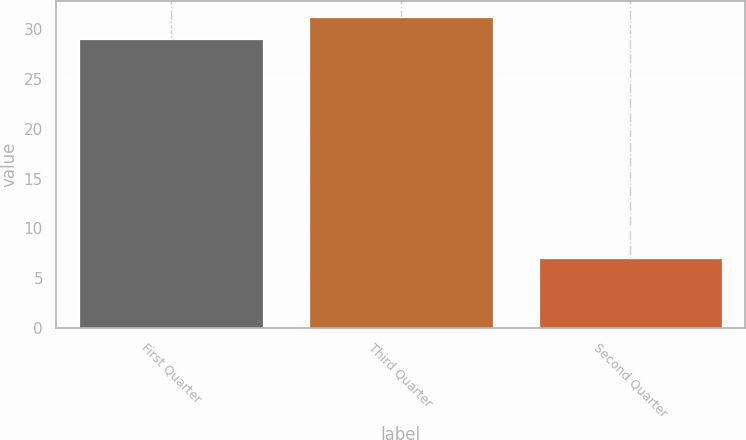Convert chart. <chart><loc_0><loc_0><loc_500><loc_500><bar_chart><fcel>First Quarter<fcel>Third Quarter<fcel>Second Quarter<nl><fcel>29<fcel>31.25<fcel>7.03<nl></chart> 